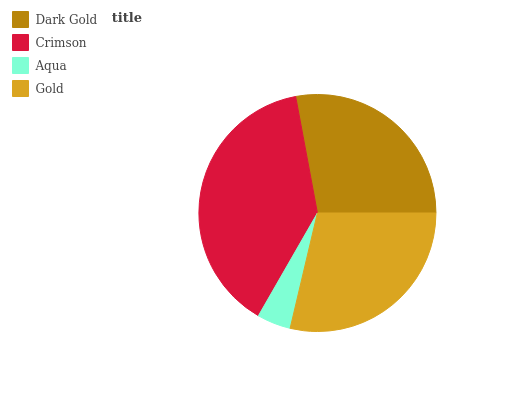Is Aqua the minimum?
Answer yes or no. Yes. Is Crimson the maximum?
Answer yes or no. Yes. Is Crimson the minimum?
Answer yes or no. No. Is Aqua the maximum?
Answer yes or no. No. Is Crimson greater than Aqua?
Answer yes or no. Yes. Is Aqua less than Crimson?
Answer yes or no. Yes. Is Aqua greater than Crimson?
Answer yes or no. No. Is Crimson less than Aqua?
Answer yes or no. No. Is Gold the high median?
Answer yes or no. Yes. Is Dark Gold the low median?
Answer yes or no. Yes. Is Aqua the high median?
Answer yes or no. No. Is Aqua the low median?
Answer yes or no. No. 